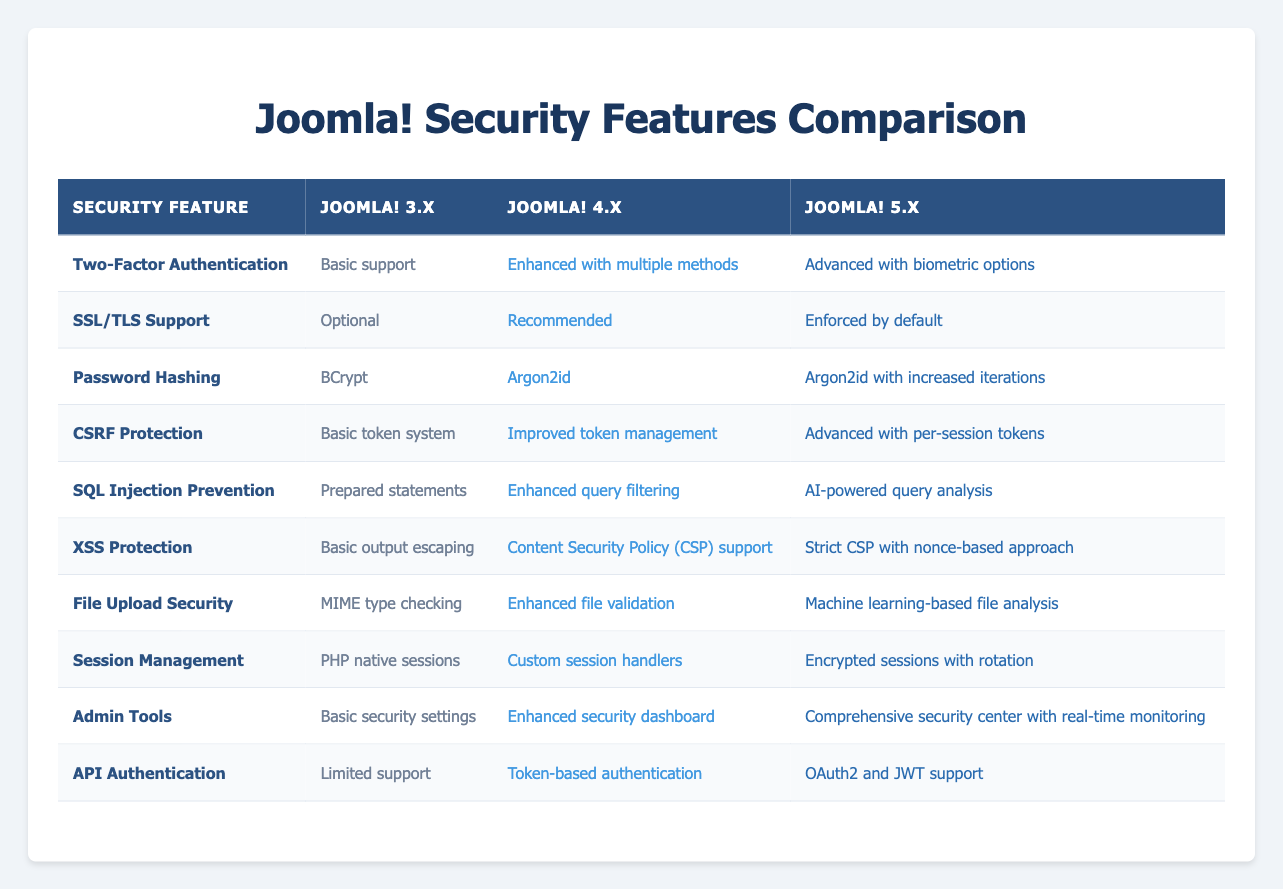What is the password hashing method used in Joomla! 4.x? The table states that Joomla! 4.x uses "Argon2id" for password hashing.
Answer: Argon2id Does Joomla! 5.x offer better file upload security than Joomla! 3.x? By comparing the rows for "File Upload Security", Joomla! 3.x has "MIME type checking" while Joomla! 5.x has "Machine learning-based file analysis", which is an improvement.
Answer: Yes What is the difference in session management between Joomla! 4.x and Joomla! 5.x? Joomla! 4.x uses "Custom session handlers", whereas Joomla! 5.x improves upon this with "Encrypted sessions with rotation", indicating a significant enhancement in security.
Answer: Encrypted sessions with rotation Is CSRF protection in Joomla! 4.x better than in Joomla! 3.x? The table indicates that Joomla! 4.x has "Improved token management" compared to the "Basic token system" of Joomla! 3.x, suggesting an upgrade in CSRF protection.
Answer: Yes Which Joomla! version enforces SSL/TLS support by default? According to the table, only Joomla! 5.x has "Enforced by default" for SSL/TLS support, indicating that it is stricter compared to previous versions.
Answer: Joomla! 5.x What improvements in API authentication are seen from Joomla! 3.x to Joomla! 5.x? Joomla! 3.x has "Limited support" for API authentication, while Joomla! 5.x introduces "OAuth2 and JWT support", showcasing a significant enhancement in functionality and security.
Answer: OAuth2 and JWT support How many security features does Joomla! 5.x provide compared to Joomla! 3.x? The table shows 10 security features, and Joomla! 5.x generally has more advanced implementations. Each feature in Joomla! 5.x represents an upgrade from Joomla! 3.x.
Answer: 10 features Is it true that Joomla! 4.x has a security dashboard? Yes, the table states that Joomla! 4.x features an "Enhanced security dashboard," confirming that this capability exists.
Answer: Yes What security feature in Joomla! 5.x significantly improves SQL injection prevention compared to Joomla! 3.x? The table indicates that Joomla! 5.x utilizes "AI-powered query analysis" for SQL injection prevention, whereas Joomla! 3.x used only "Prepared statements", showcasing a notable advancement.
Answer: AI-powered query analysis 